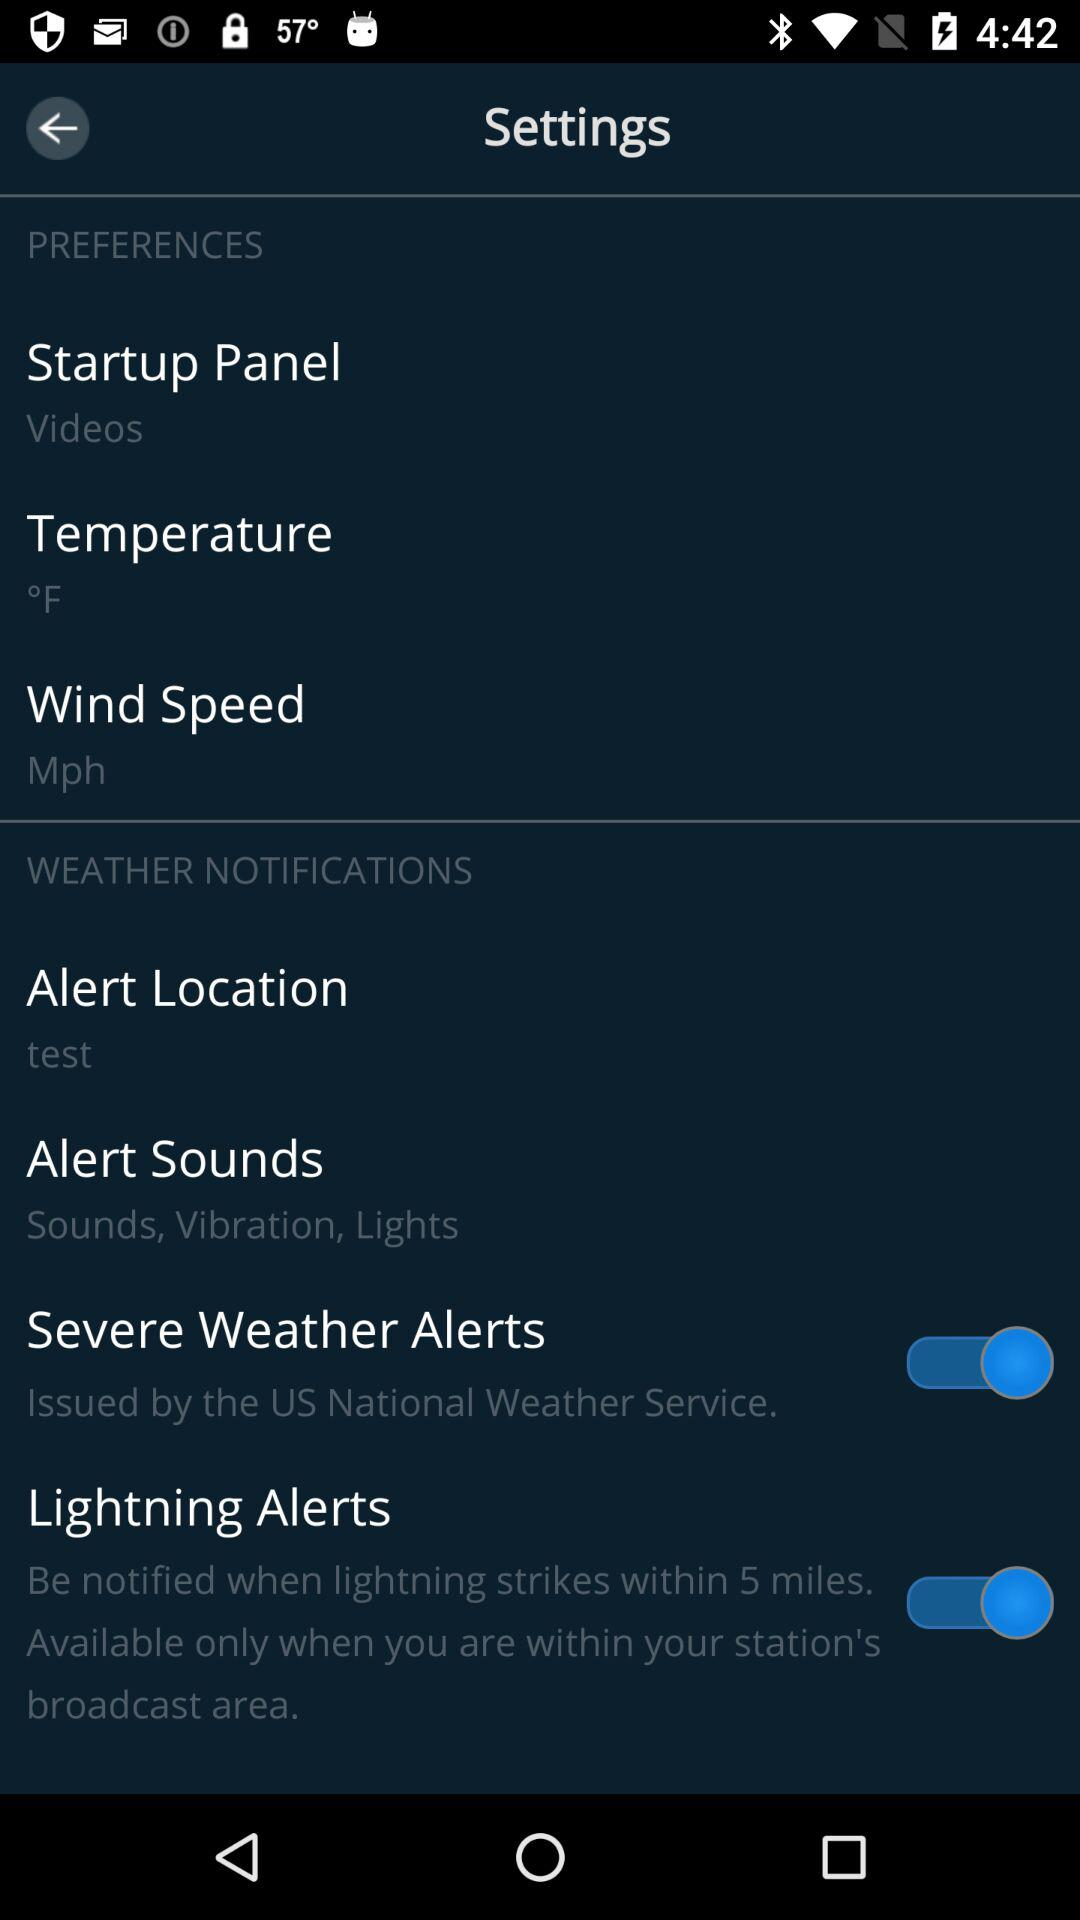Which sounds are available in "Alert Sounds"?
When the provided information is insufficient, respond with <no answer>. <no answer> 